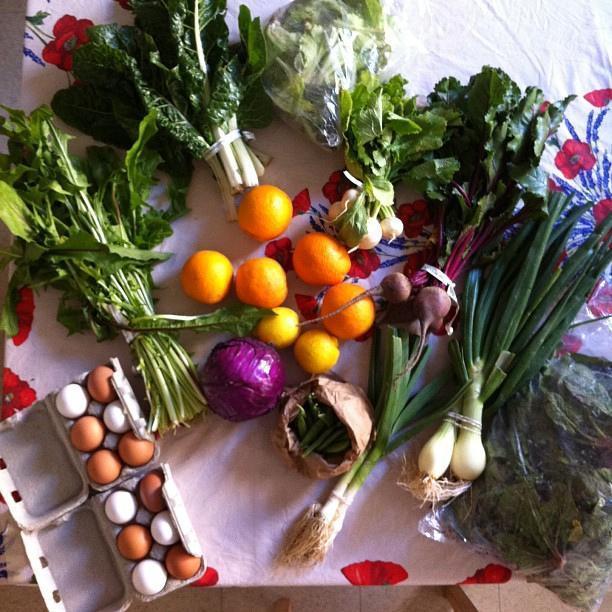How many brown eggs are there?
Give a very brief answer. 7. How many oranges are there?
Give a very brief answer. 4. How many horses are in the picture?
Give a very brief answer. 0. 